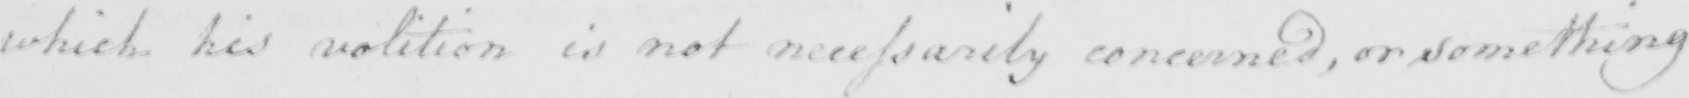Can you read and transcribe this handwriting? which his volition is not necessarily concerned , or something 